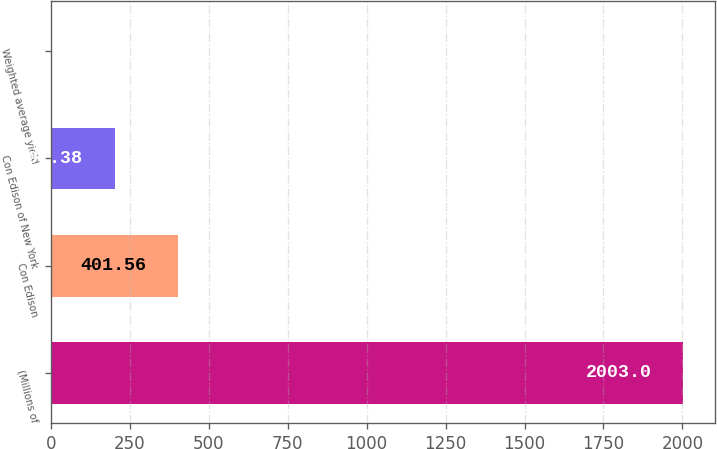Convert chart to OTSL. <chart><loc_0><loc_0><loc_500><loc_500><bar_chart><fcel>(Millions of<fcel>Con Edison<fcel>Con Edison of New York<fcel>Weighted average yield<nl><fcel>2003<fcel>401.56<fcel>201.38<fcel>1.2<nl></chart> 